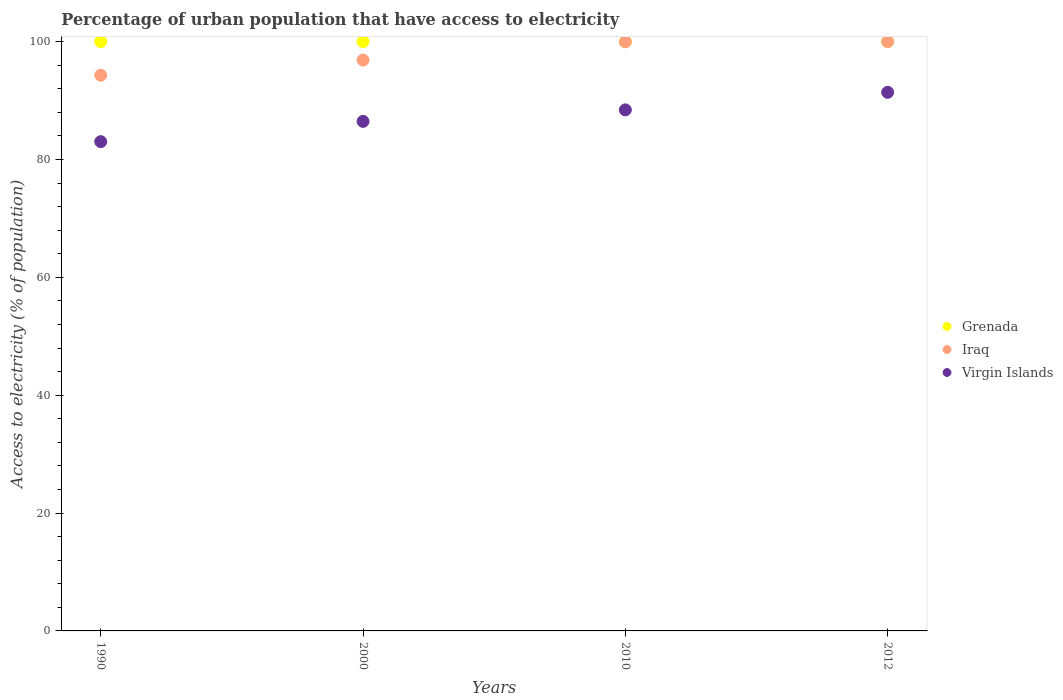Is the number of dotlines equal to the number of legend labels?
Your answer should be very brief. Yes. What is the percentage of urban population that have access to electricity in Grenada in 2010?
Give a very brief answer. 100. Across all years, what is the maximum percentage of urban population that have access to electricity in Iraq?
Offer a very short reply. 100. Across all years, what is the minimum percentage of urban population that have access to electricity in Iraq?
Provide a short and direct response. 94.29. What is the total percentage of urban population that have access to electricity in Grenada in the graph?
Make the answer very short. 400. What is the difference between the percentage of urban population that have access to electricity in Iraq in 2000 and that in 2010?
Provide a succinct answer. -3.1. What is the difference between the percentage of urban population that have access to electricity in Iraq in 1990 and the percentage of urban population that have access to electricity in Virgin Islands in 2000?
Give a very brief answer. 7.83. What is the average percentage of urban population that have access to electricity in Iraq per year?
Provide a succinct answer. 97.78. In the year 2010, what is the difference between the percentage of urban population that have access to electricity in Virgin Islands and percentage of urban population that have access to electricity in Iraq?
Your response must be concise. -11.55. In how many years, is the percentage of urban population that have access to electricity in Iraq greater than 28 %?
Offer a very short reply. 4. What is the ratio of the percentage of urban population that have access to electricity in Virgin Islands in 2000 to that in 2012?
Ensure brevity in your answer.  0.95. Is the percentage of urban population that have access to electricity in Virgin Islands in 1990 less than that in 2012?
Your answer should be compact. Yes. Is the difference between the percentage of urban population that have access to electricity in Virgin Islands in 2000 and 2012 greater than the difference between the percentage of urban population that have access to electricity in Iraq in 2000 and 2012?
Your answer should be very brief. No. What is the difference between the highest and the second highest percentage of urban population that have access to electricity in Grenada?
Your answer should be compact. 0. What is the difference between the highest and the lowest percentage of urban population that have access to electricity in Iraq?
Offer a terse response. 5.71. In how many years, is the percentage of urban population that have access to electricity in Virgin Islands greater than the average percentage of urban population that have access to electricity in Virgin Islands taken over all years?
Keep it short and to the point. 2. Is the sum of the percentage of urban population that have access to electricity in Virgin Islands in 1990 and 2000 greater than the maximum percentage of urban population that have access to electricity in Grenada across all years?
Give a very brief answer. Yes. Does the percentage of urban population that have access to electricity in Grenada monotonically increase over the years?
Keep it short and to the point. No. How many years are there in the graph?
Give a very brief answer. 4. Are the values on the major ticks of Y-axis written in scientific E-notation?
Make the answer very short. No. Does the graph contain grids?
Keep it short and to the point. No. Where does the legend appear in the graph?
Provide a succinct answer. Center right. How many legend labels are there?
Your response must be concise. 3. How are the legend labels stacked?
Offer a terse response. Vertical. What is the title of the graph?
Provide a succinct answer. Percentage of urban population that have access to electricity. What is the label or title of the X-axis?
Ensure brevity in your answer.  Years. What is the label or title of the Y-axis?
Ensure brevity in your answer.  Access to electricity (% of population). What is the Access to electricity (% of population) of Iraq in 1990?
Your answer should be compact. 94.29. What is the Access to electricity (% of population) of Virgin Islands in 1990?
Give a very brief answer. 83.02. What is the Access to electricity (% of population) of Grenada in 2000?
Your answer should be compact. 100. What is the Access to electricity (% of population) of Iraq in 2000?
Your answer should be compact. 96.86. What is the Access to electricity (% of population) of Virgin Islands in 2000?
Your response must be concise. 86.46. What is the Access to electricity (% of population) of Grenada in 2010?
Your answer should be very brief. 100. What is the Access to electricity (% of population) in Iraq in 2010?
Make the answer very short. 99.96. What is the Access to electricity (% of population) in Virgin Islands in 2010?
Your answer should be very brief. 88.41. What is the Access to electricity (% of population) of Grenada in 2012?
Provide a short and direct response. 100. What is the Access to electricity (% of population) in Virgin Islands in 2012?
Your answer should be compact. 91.39. Across all years, what is the maximum Access to electricity (% of population) of Iraq?
Make the answer very short. 100. Across all years, what is the maximum Access to electricity (% of population) of Virgin Islands?
Make the answer very short. 91.39. Across all years, what is the minimum Access to electricity (% of population) in Iraq?
Offer a very short reply. 94.29. Across all years, what is the minimum Access to electricity (% of population) of Virgin Islands?
Make the answer very short. 83.02. What is the total Access to electricity (% of population) of Grenada in the graph?
Ensure brevity in your answer.  400. What is the total Access to electricity (% of population) in Iraq in the graph?
Make the answer very short. 391.12. What is the total Access to electricity (% of population) of Virgin Islands in the graph?
Your response must be concise. 349.28. What is the difference between the Access to electricity (% of population) in Iraq in 1990 and that in 2000?
Keep it short and to the point. -2.57. What is the difference between the Access to electricity (% of population) of Virgin Islands in 1990 and that in 2000?
Your answer should be very brief. -3.44. What is the difference between the Access to electricity (% of population) in Grenada in 1990 and that in 2010?
Offer a terse response. 0. What is the difference between the Access to electricity (% of population) of Iraq in 1990 and that in 2010?
Offer a terse response. -5.67. What is the difference between the Access to electricity (% of population) in Virgin Islands in 1990 and that in 2010?
Provide a succinct answer. -5.39. What is the difference between the Access to electricity (% of population) of Grenada in 1990 and that in 2012?
Keep it short and to the point. 0. What is the difference between the Access to electricity (% of population) of Iraq in 1990 and that in 2012?
Your answer should be compact. -5.71. What is the difference between the Access to electricity (% of population) of Virgin Islands in 1990 and that in 2012?
Provide a short and direct response. -8.37. What is the difference between the Access to electricity (% of population) of Iraq in 2000 and that in 2010?
Provide a short and direct response. -3.1. What is the difference between the Access to electricity (% of population) in Virgin Islands in 2000 and that in 2010?
Offer a terse response. -1.95. What is the difference between the Access to electricity (% of population) in Iraq in 2000 and that in 2012?
Your answer should be compact. -3.14. What is the difference between the Access to electricity (% of population) of Virgin Islands in 2000 and that in 2012?
Your answer should be very brief. -4.93. What is the difference between the Access to electricity (% of population) of Iraq in 2010 and that in 2012?
Give a very brief answer. -0.04. What is the difference between the Access to electricity (% of population) of Virgin Islands in 2010 and that in 2012?
Offer a very short reply. -2.98. What is the difference between the Access to electricity (% of population) of Grenada in 1990 and the Access to electricity (% of population) of Iraq in 2000?
Provide a succinct answer. 3.14. What is the difference between the Access to electricity (% of population) in Grenada in 1990 and the Access to electricity (% of population) in Virgin Islands in 2000?
Ensure brevity in your answer.  13.54. What is the difference between the Access to electricity (% of population) in Iraq in 1990 and the Access to electricity (% of population) in Virgin Islands in 2000?
Give a very brief answer. 7.83. What is the difference between the Access to electricity (% of population) in Grenada in 1990 and the Access to electricity (% of population) in Iraq in 2010?
Provide a succinct answer. 0.04. What is the difference between the Access to electricity (% of population) of Grenada in 1990 and the Access to electricity (% of population) of Virgin Islands in 2010?
Offer a very short reply. 11.59. What is the difference between the Access to electricity (% of population) of Iraq in 1990 and the Access to electricity (% of population) of Virgin Islands in 2010?
Offer a very short reply. 5.88. What is the difference between the Access to electricity (% of population) in Grenada in 1990 and the Access to electricity (% of population) in Iraq in 2012?
Provide a succinct answer. 0. What is the difference between the Access to electricity (% of population) of Grenada in 1990 and the Access to electricity (% of population) of Virgin Islands in 2012?
Provide a short and direct response. 8.61. What is the difference between the Access to electricity (% of population) of Grenada in 2000 and the Access to electricity (% of population) of Iraq in 2010?
Offer a terse response. 0.04. What is the difference between the Access to electricity (% of population) of Grenada in 2000 and the Access to electricity (% of population) of Virgin Islands in 2010?
Your response must be concise. 11.59. What is the difference between the Access to electricity (% of population) in Iraq in 2000 and the Access to electricity (% of population) in Virgin Islands in 2010?
Offer a very short reply. 8.45. What is the difference between the Access to electricity (% of population) in Grenada in 2000 and the Access to electricity (% of population) in Virgin Islands in 2012?
Provide a succinct answer. 8.61. What is the difference between the Access to electricity (% of population) of Iraq in 2000 and the Access to electricity (% of population) of Virgin Islands in 2012?
Your answer should be very brief. 5.47. What is the difference between the Access to electricity (% of population) in Grenada in 2010 and the Access to electricity (% of population) in Iraq in 2012?
Offer a very short reply. 0. What is the difference between the Access to electricity (% of population) in Grenada in 2010 and the Access to electricity (% of population) in Virgin Islands in 2012?
Keep it short and to the point. 8.61. What is the difference between the Access to electricity (% of population) in Iraq in 2010 and the Access to electricity (% of population) in Virgin Islands in 2012?
Ensure brevity in your answer.  8.57. What is the average Access to electricity (% of population) of Grenada per year?
Your response must be concise. 100. What is the average Access to electricity (% of population) in Iraq per year?
Your answer should be compact. 97.78. What is the average Access to electricity (% of population) of Virgin Islands per year?
Offer a terse response. 87.32. In the year 1990, what is the difference between the Access to electricity (% of population) of Grenada and Access to electricity (% of population) of Iraq?
Provide a succinct answer. 5.71. In the year 1990, what is the difference between the Access to electricity (% of population) in Grenada and Access to electricity (% of population) in Virgin Islands?
Offer a terse response. 16.98. In the year 1990, what is the difference between the Access to electricity (% of population) of Iraq and Access to electricity (% of population) of Virgin Islands?
Provide a succinct answer. 11.27. In the year 2000, what is the difference between the Access to electricity (% of population) in Grenada and Access to electricity (% of population) in Iraq?
Your response must be concise. 3.14. In the year 2000, what is the difference between the Access to electricity (% of population) in Grenada and Access to electricity (% of population) in Virgin Islands?
Offer a terse response. 13.54. In the year 2000, what is the difference between the Access to electricity (% of population) in Iraq and Access to electricity (% of population) in Virgin Islands?
Offer a terse response. 10.4. In the year 2010, what is the difference between the Access to electricity (% of population) of Grenada and Access to electricity (% of population) of Iraq?
Your response must be concise. 0.04. In the year 2010, what is the difference between the Access to electricity (% of population) in Grenada and Access to electricity (% of population) in Virgin Islands?
Provide a short and direct response. 11.59. In the year 2010, what is the difference between the Access to electricity (% of population) in Iraq and Access to electricity (% of population) in Virgin Islands?
Your response must be concise. 11.55. In the year 2012, what is the difference between the Access to electricity (% of population) in Grenada and Access to electricity (% of population) in Virgin Islands?
Your answer should be very brief. 8.61. In the year 2012, what is the difference between the Access to electricity (% of population) of Iraq and Access to electricity (% of population) of Virgin Islands?
Your response must be concise. 8.61. What is the ratio of the Access to electricity (% of population) of Grenada in 1990 to that in 2000?
Keep it short and to the point. 1. What is the ratio of the Access to electricity (% of population) in Iraq in 1990 to that in 2000?
Keep it short and to the point. 0.97. What is the ratio of the Access to electricity (% of population) of Virgin Islands in 1990 to that in 2000?
Keep it short and to the point. 0.96. What is the ratio of the Access to electricity (% of population) in Iraq in 1990 to that in 2010?
Keep it short and to the point. 0.94. What is the ratio of the Access to electricity (% of population) of Virgin Islands in 1990 to that in 2010?
Your answer should be very brief. 0.94. What is the ratio of the Access to electricity (% of population) in Iraq in 1990 to that in 2012?
Offer a very short reply. 0.94. What is the ratio of the Access to electricity (% of population) in Virgin Islands in 1990 to that in 2012?
Your answer should be compact. 0.91. What is the ratio of the Access to electricity (% of population) of Iraq in 2000 to that in 2010?
Offer a very short reply. 0.97. What is the ratio of the Access to electricity (% of population) of Virgin Islands in 2000 to that in 2010?
Give a very brief answer. 0.98. What is the ratio of the Access to electricity (% of population) of Grenada in 2000 to that in 2012?
Provide a succinct answer. 1. What is the ratio of the Access to electricity (% of population) in Iraq in 2000 to that in 2012?
Keep it short and to the point. 0.97. What is the ratio of the Access to electricity (% of population) of Virgin Islands in 2000 to that in 2012?
Your answer should be compact. 0.95. What is the ratio of the Access to electricity (% of population) in Grenada in 2010 to that in 2012?
Your answer should be compact. 1. What is the ratio of the Access to electricity (% of population) of Iraq in 2010 to that in 2012?
Give a very brief answer. 1. What is the ratio of the Access to electricity (% of population) in Virgin Islands in 2010 to that in 2012?
Provide a short and direct response. 0.97. What is the difference between the highest and the second highest Access to electricity (% of population) of Grenada?
Keep it short and to the point. 0. What is the difference between the highest and the second highest Access to electricity (% of population) in Iraq?
Keep it short and to the point. 0.04. What is the difference between the highest and the second highest Access to electricity (% of population) of Virgin Islands?
Your response must be concise. 2.98. What is the difference between the highest and the lowest Access to electricity (% of population) in Grenada?
Your answer should be compact. 0. What is the difference between the highest and the lowest Access to electricity (% of population) in Iraq?
Ensure brevity in your answer.  5.71. What is the difference between the highest and the lowest Access to electricity (% of population) in Virgin Islands?
Offer a very short reply. 8.37. 